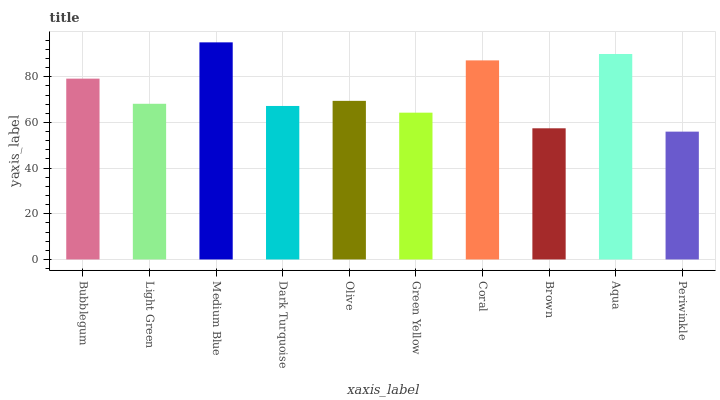Is Light Green the minimum?
Answer yes or no. No. Is Light Green the maximum?
Answer yes or no. No. Is Bubblegum greater than Light Green?
Answer yes or no. Yes. Is Light Green less than Bubblegum?
Answer yes or no. Yes. Is Light Green greater than Bubblegum?
Answer yes or no. No. Is Bubblegum less than Light Green?
Answer yes or no. No. Is Olive the high median?
Answer yes or no. Yes. Is Light Green the low median?
Answer yes or no. Yes. Is Brown the high median?
Answer yes or no. No. Is Brown the low median?
Answer yes or no. No. 